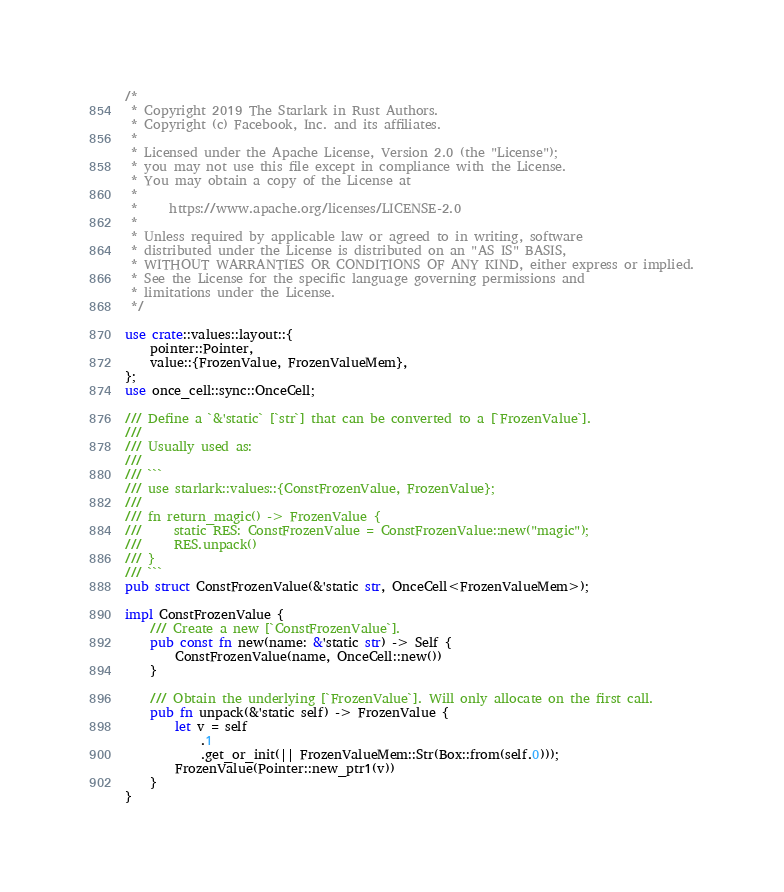Convert code to text. <code><loc_0><loc_0><loc_500><loc_500><_Rust_>/*
 * Copyright 2019 The Starlark in Rust Authors.
 * Copyright (c) Facebook, Inc. and its affiliates.
 *
 * Licensed under the Apache License, Version 2.0 (the "License");
 * you may not use this file except in compliance with the License.
 * You may obtain a copy of the License at
 *
 *     https://www.apache.org/licenses/LICENSE-2.0
 *
 * Unless required by applicable law or agreed to in writing, software
 * distributed under the License is distributed on an "AS IS" BASIS,
 * WITHOUT WARRANTIES OR CONDITIONS OF ANY KIND, either express or implied.
 * See the License for the specific language governing permissions and
 * limitations under the License.
 */

use crate::values::layout::{
    pointer::Pointer,
    value::{FrozenValue, FrozenValueMem},
};
use once_cell::sync::OnceCell;

/// Define a `&'static` [`str`] that can be converted to a [`FrozenValue`].
///
/// Usually used as:
///
/// ```
/// use starlark::values::{ConstFrozenValue, FrozenValue};
///
/// fn return_magic() -> FrozenValue {
///     static RES: ConstFrozenValue = ConstFrozenValue::new("magic");
///     RES.unpack()
/// }
/// ```
pub struct ConstFrozenValue(&'static str, OnceCell<FrozenValueMem>);

impl ConstFrozenValue {
    /// Create a new [`ConstFrozenValue`].
    pub const fn new(name: &'static str) -> Self {
        ConstFrozenValue(name, OnceCell::new())
    }

    /// Obtain the underlying [`FrozenValue`]. Will only allocate on the first call.
    pub fn unpack(&'static self) -> FrozenValue {
        let v = self
            .1
            .get_or_init(|| FrozenValueMem::Str(Box::from(self.0)));
        FrozenValue(Pointer::new_ptr1(v))
    }
}
</code> 